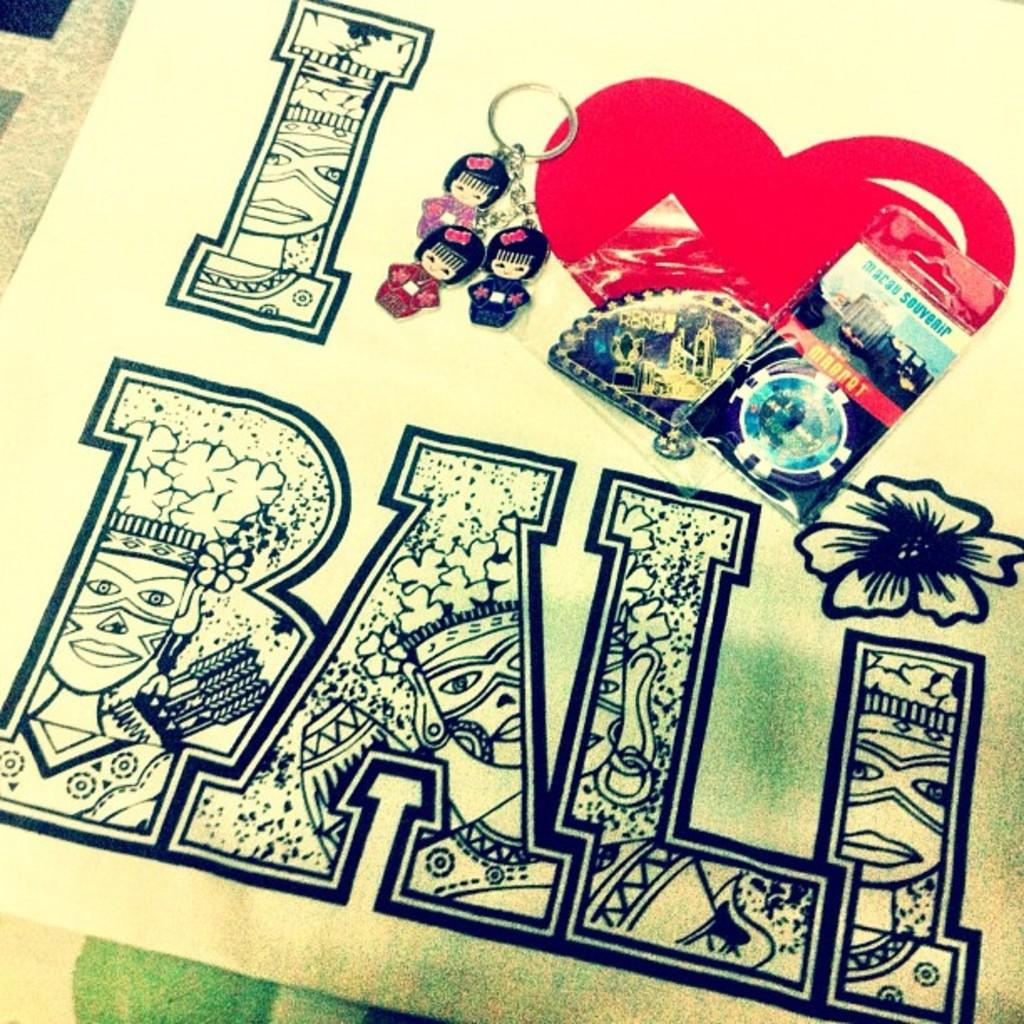What is the main subject of the image? The main subject of the image is a key chain of dolls. Are there any symbols or additional elements in the image? Yes, there is a heart symbol in red color in the image. Can you describe the unspecified objects present in the image? Unfortunately, the facts provided do not specify the nature of the unspecified objects in the image. What type of music can be heard playing in the background of the image? There is no music present in the image, as it is a static representation of a key chain and a heart symbol. 